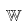Convert formula to latex. <formula><loc_0><loc_0><loc_500><loc_500>\mathbb { W }</formula> 